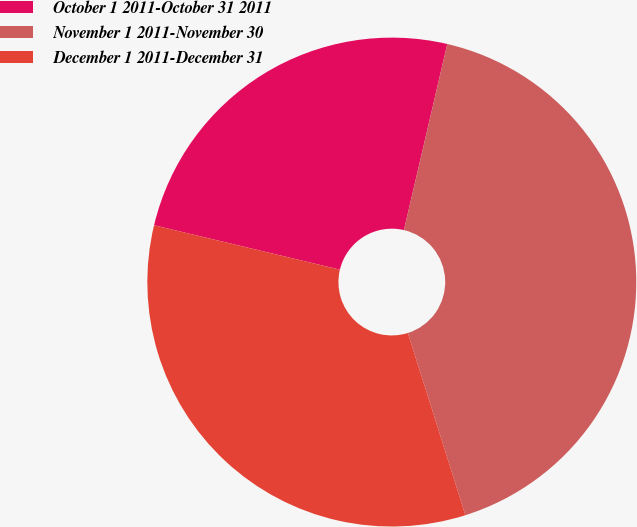Convert chart. <chart><loc_0><loc_0><loc_500><loc_500><pie_chart><fcel>October 1 2011-October 31 2011<fcel>November 1 2011-November 30<fcel>December 1 2011-December 31<nl><fcel>24.91%<fcel>41.49%<fcel>33.6%<nl></chart> 